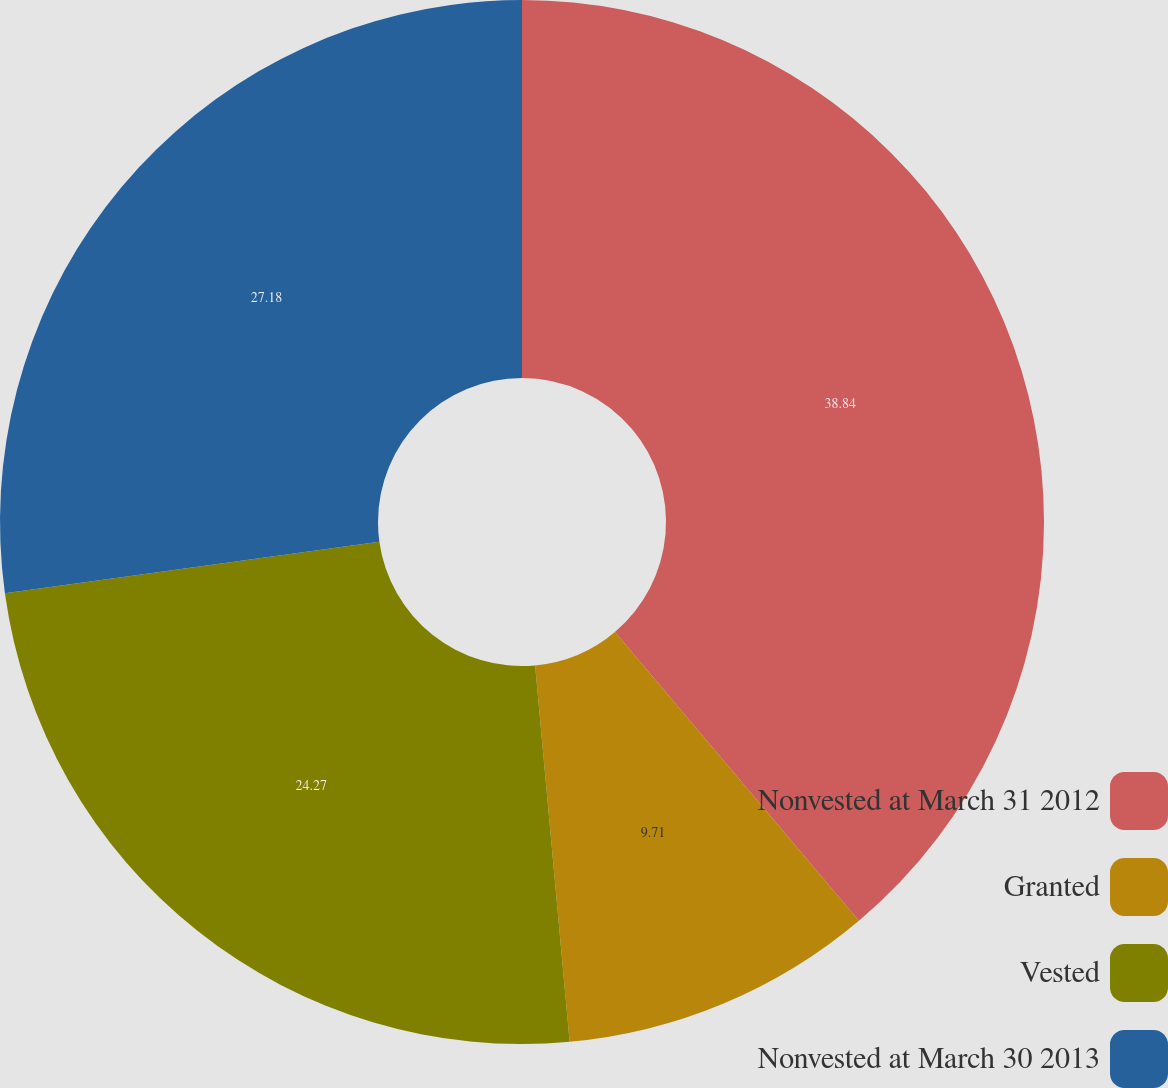Convert chart to OTSL. <chart><loc_0><loc_0><loc_500><loc_500><pie_chart><fcel>Nonvested at March 31 2012<fcel>Granted<fcel>Vested<fcel>Nonvested at March 30 2013<nl><fcel>38.83%<fcel>9.71%<fcel>24.27%<fcel>27.18%<nl></chart> 